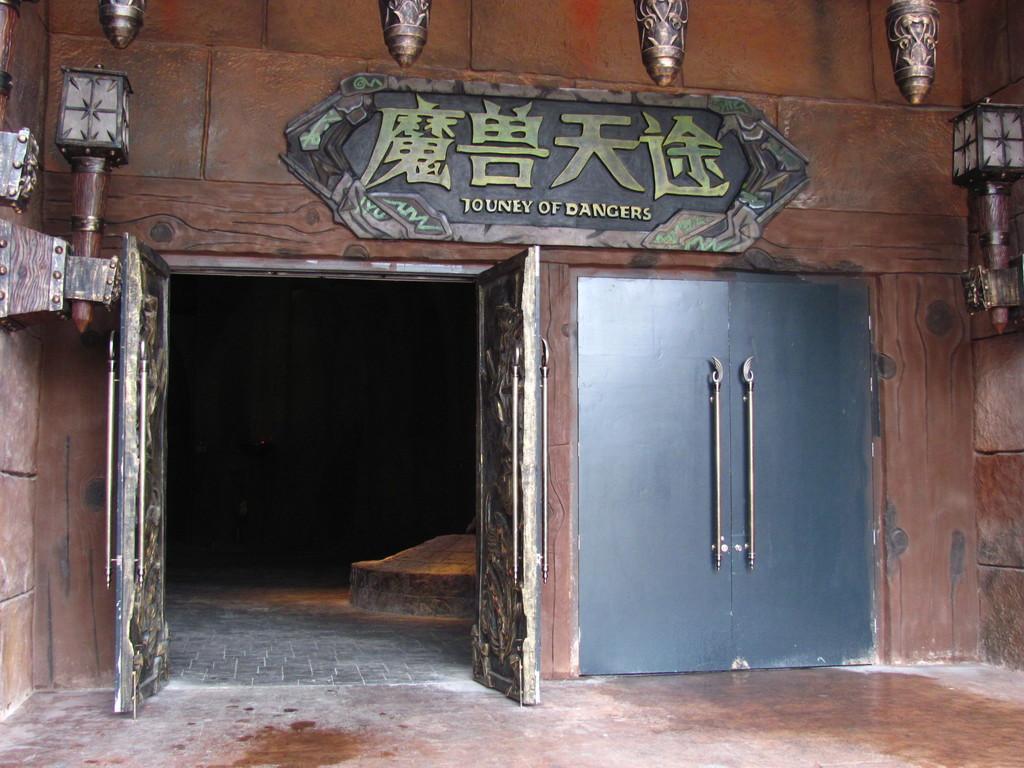Describe this image in one or two sentences. In the image there is a wooden wall. On the wooden wall there are doors. On the left and right side of the image on the walls there are lamps. And also there is a board with text on it. At the top of the image there are poles. 